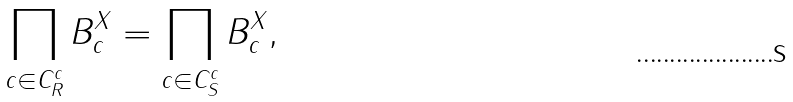<formula> <loc_0><loc_0><loc_500><loc_500>\prod _ { c \in C _ { R } ^ { c } } B _ { c } ^ { X } = \prod _ { c \in C _ { S } ^ { c } } B _ { c } ^ { X } ,</formula> 